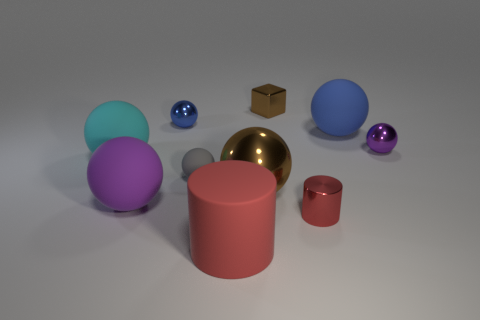The big metal sphere has what color?
Ensure brevity in your answer.  Brown. What color is the cylinder that is the same size as the block?
Provide a short and direct response. Red. Is there a large matte ball of the same color as the small shiny cylinder?
Give a very brief answer. No. There is a big rubber object that is right of the small brown metallic block; is its shape the same as the small object to the right of the red metal object?
Offer a terse response. Yes. What size is the shiny sphere that is the same color as the small shiny block?
Ensure brevity in your answer.  Large. What number of other things are the same size as the brown metallic sphere?
Keep it short and to the point. 4. Do the tiny metal cube and the large rubber ball right of the tiny blue thing have the same color?
Your answer should be compact. No. Are there fewer things in front of the cyan matte ball than rubber objects that are left of the big red rubber cylinder?
Make the answer very short. No. There is a tiny object that is on the right side of the cube and behind the gray object; what color is it?
Your answer should be compact. Purple. There is a blue metallic ball; is it the same size as the matte thing right of the shiny cube?
Make the answer very short. No. 